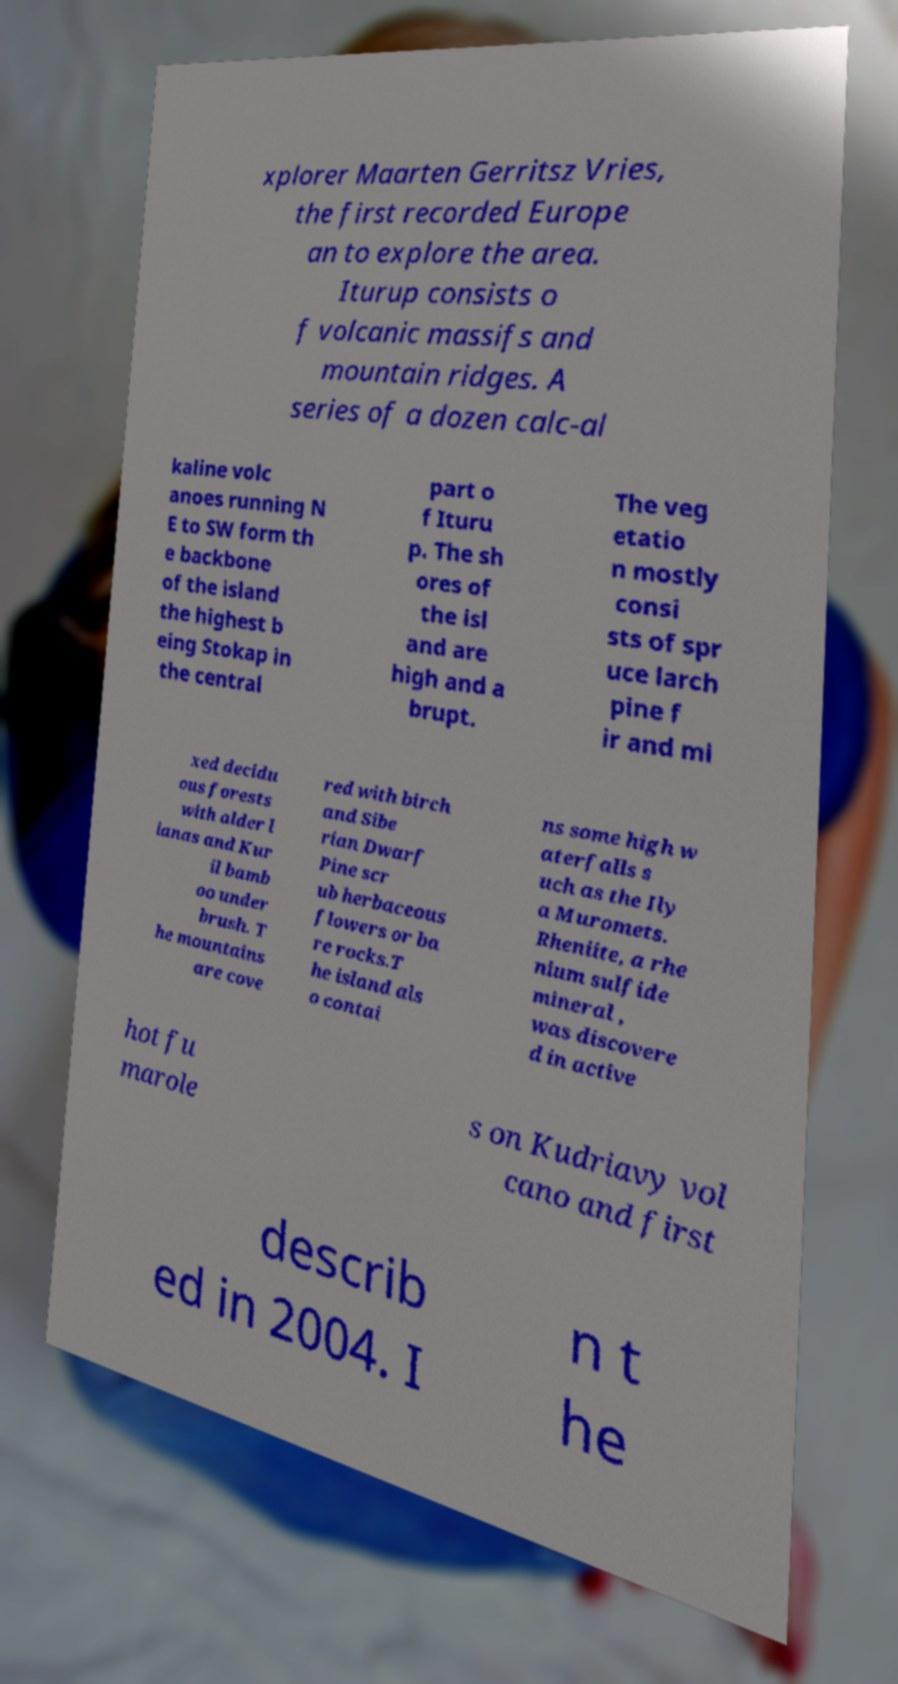There's text embedded in this image that I need extracted. Can you transcribe it verbatim? xplorer Maarten Gerritsz Vries, the first recorded Europe an to explore the area. Iturup consists o f volcanic massifs and mountain ridges. A series of a dozen calc-al kaline volc anoes running N E to SW form th e backbone of the island the highest b eing Stokap in the central part o f Ituru p. The sh ores of the isl and are high and a brupt. The veg etatio n mostly consi sts of spr uce larch pine f ir and mi xed decidu ous forests with alder l ianas and Kur il bamb oo under brush. T he mountains are cove red with birch and Sibe rian Dwarf Pine scr ub herbaceous flowers or ba re rocks.T he island als o contai ns some high w aterfalls s uch as the Ily a Muromets. Rheniite, a rhe nium sulfide mineral , was discovere d in active hot fu marole s on Kudriavy vol cano and first describ ed in 2004. I n t he 